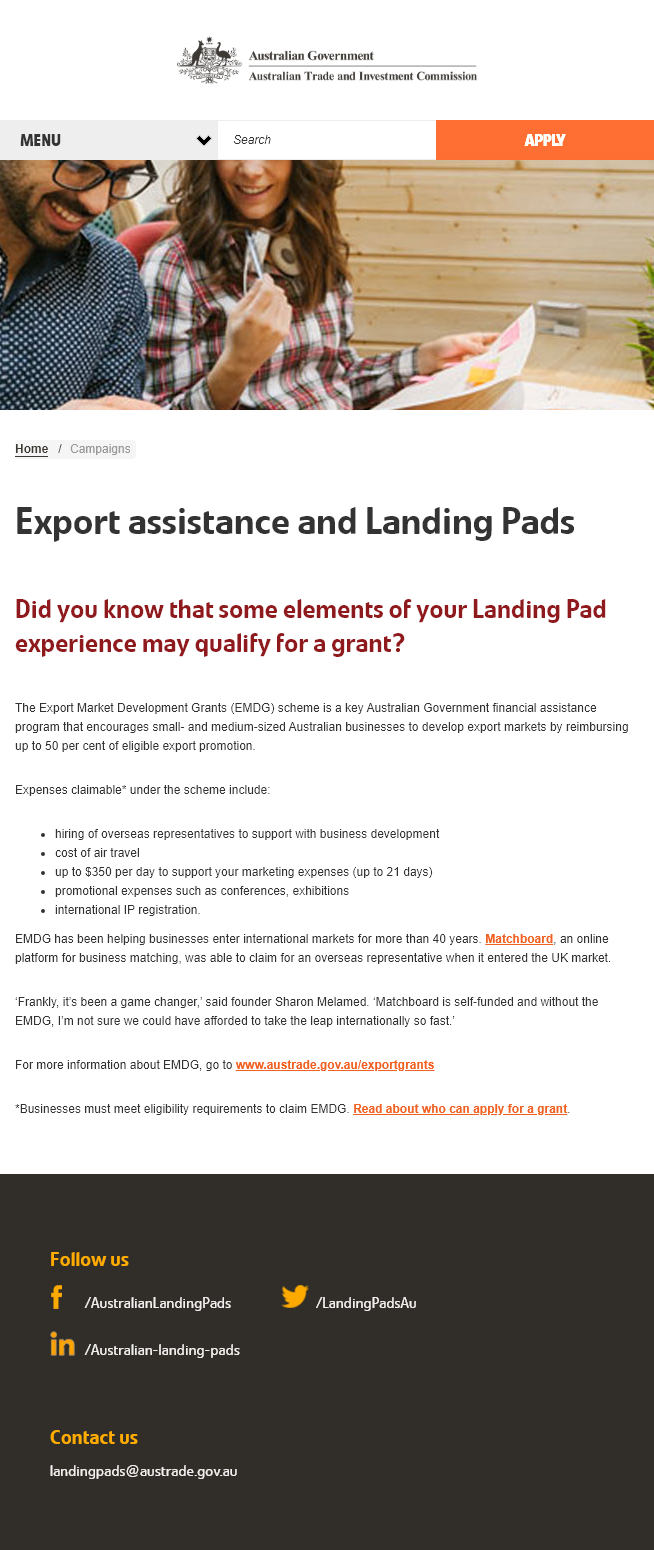Outline some significant characteristics in this image. The EMDG (Export Market Development Grants) scheme serves the purpose of incentivizing small and medium-sized Australian companies to expand their export markets by providing financial assistance in the form of grants. Yes, there is a cap on the amount that can be claimed under the EMDG scheme. The maximum amount that can be reimbursed is 50% of eligible export promotion expenses. The Export Market Development Grants scheme allows for claimable expenses, including the hiring of overseas representatives to support business development and the cost of air travel up to $350 per day for up to 21 days to support marketing expenses, as well as other related expenses. 